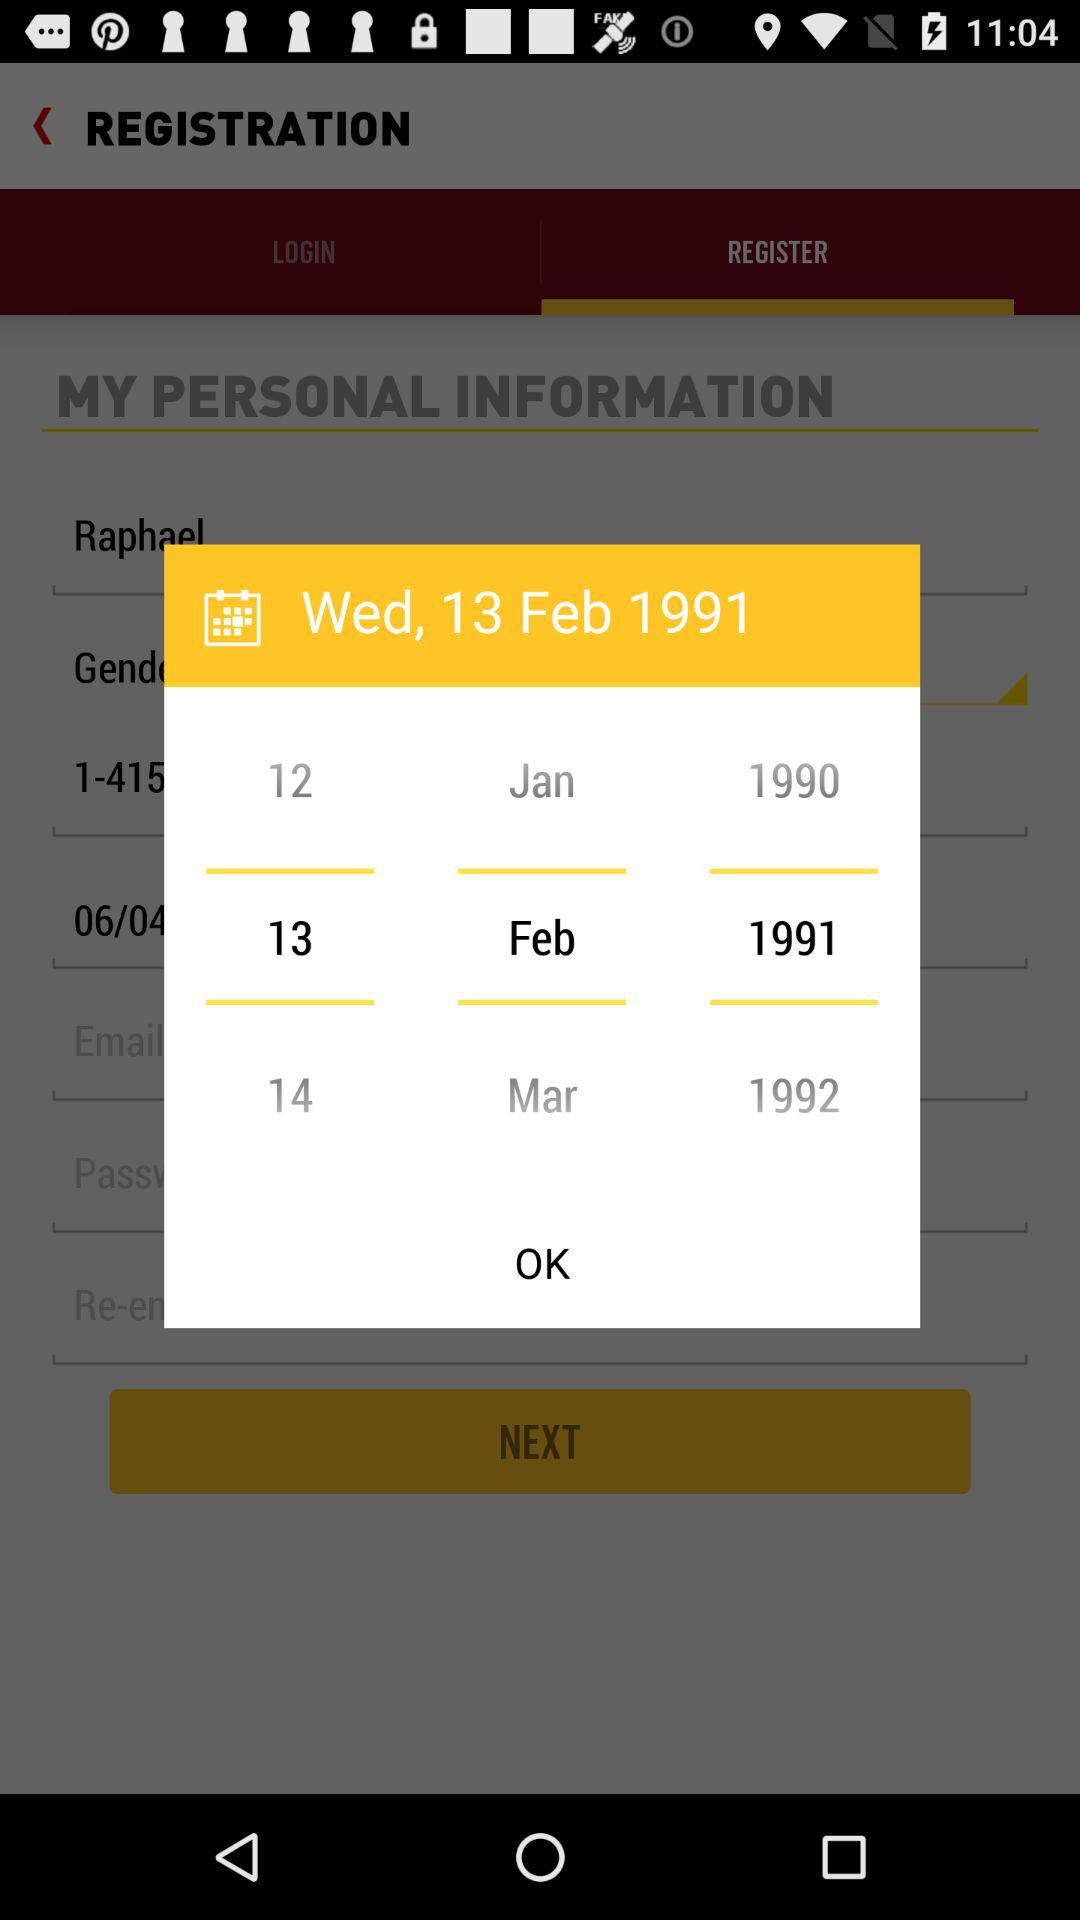How many years are shown on the calendar? There are 3 years displayed on the calendar: 1990, 1991, and 1992, which can be seen as selectable options for a user setting their birthdate in the registration process. 